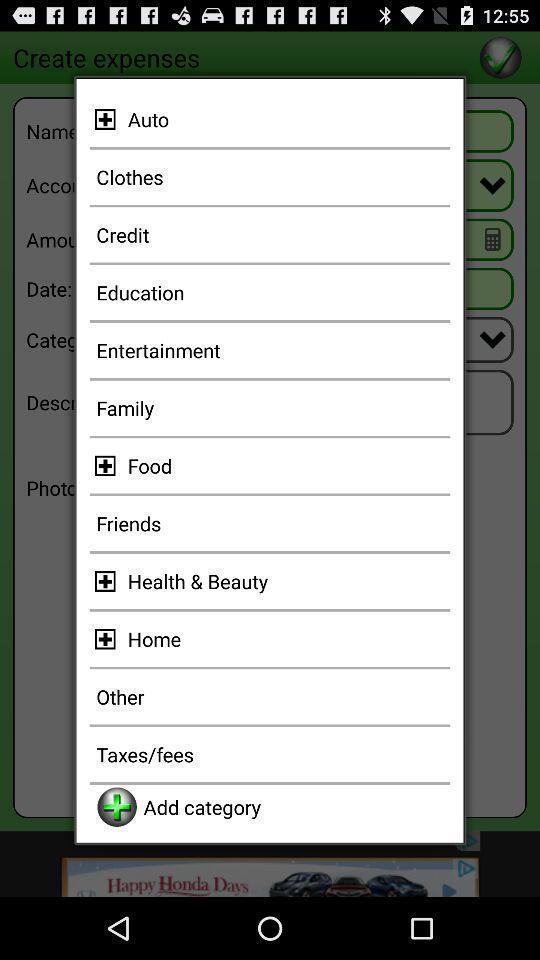Explain the elements present in this screenshot. Pop-up with options in a finance related app. 